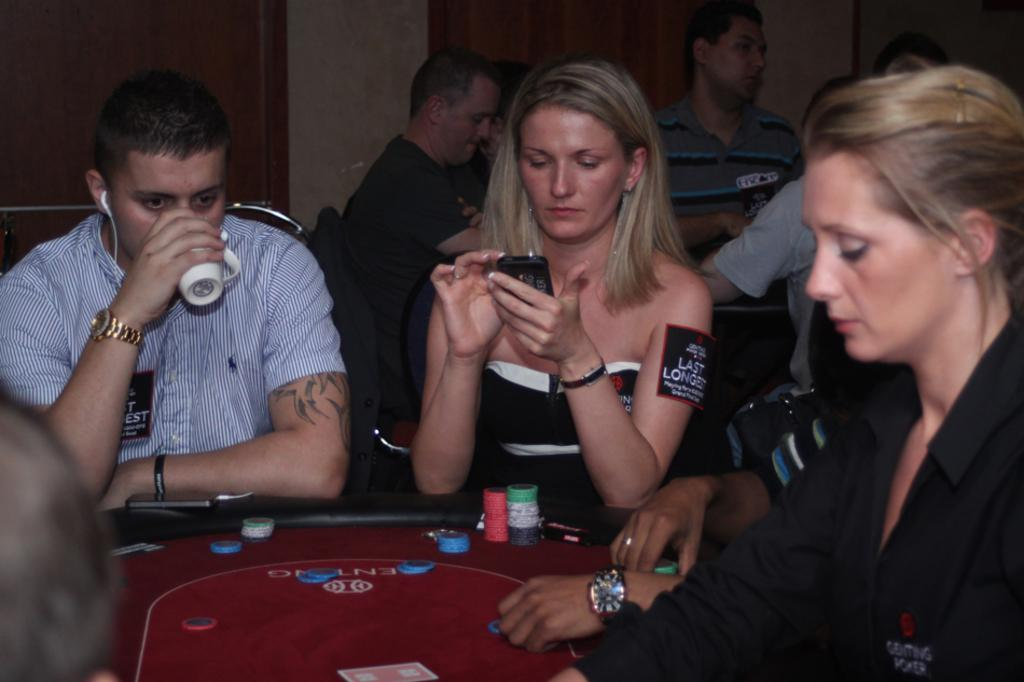What are the people in the image doing? There are people sitting on chairs in the image. What is the man holding in the image? The man is holding a cup in the image. What is the woman holding in the image? The woman is holding a phone in the image. What objects can be seen on the table in the image? There are coins on a table in the image. What type of current can be seen flowing through the phone in the image? There is no current flowing through the phone in the image; it is a static image and does not depict any electrical activity. 